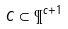<formula> <loc_0><loc_0><loc_500><loc_500>C \subset \P ^ { c + 1 }</formula> 